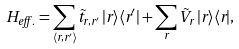<formula> <loc_0><loc_0><loc_500><loc_500>H _ { e f f . } = \sum _ { \langle { r } , { r } ^ { \prime } \rangle } \tilde { t } _ { { r } , { r } ^ { \prime } } \, | { r } \rangle \langle { r } ^ { \prime } | + \sum _ { r } \tilde { V } _ { r } \, | { r } \rangle \langle { r } | ,</formula> 